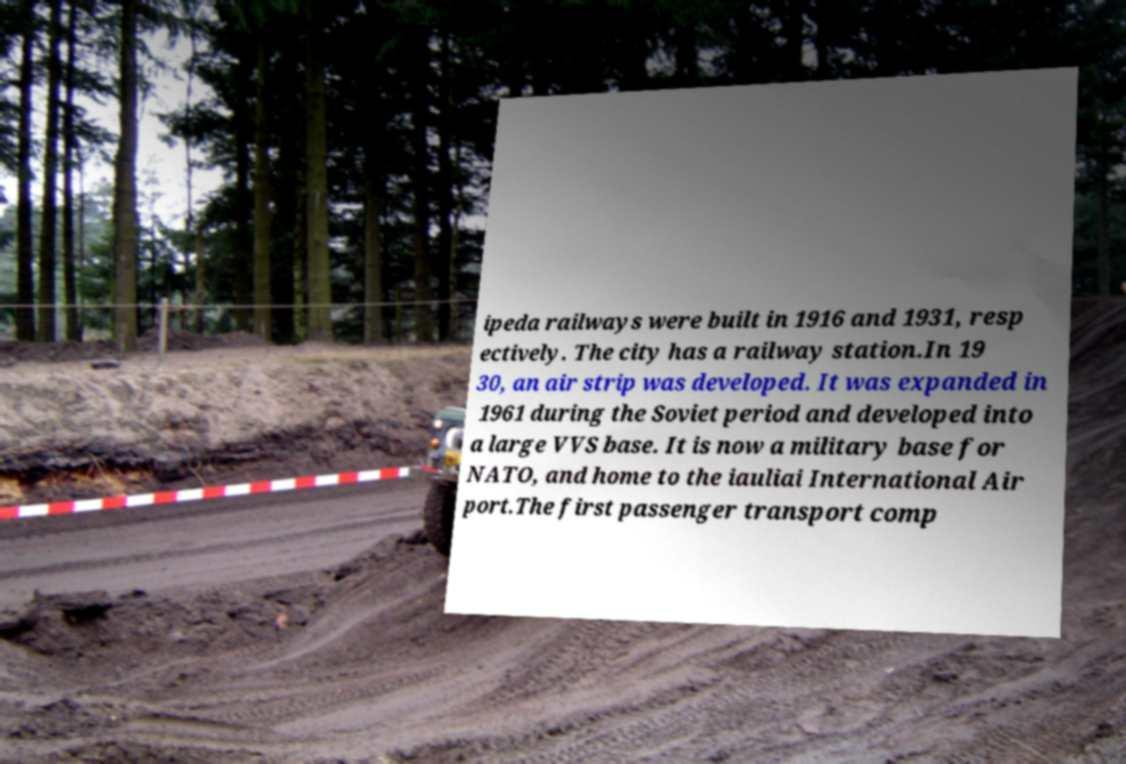Could you assist in decoding the text presented in this image and type it out clearly? ipeda railways were built in 1916 and 1931, resp ectively. The city has a railway station.In 19 30, an air strip was developed. It was expanded in 1961 during the Soviet period and developed into a large VVS base. It is now a military base for NATO, and home to the iauliai International Air port.The first passenger transport comp 